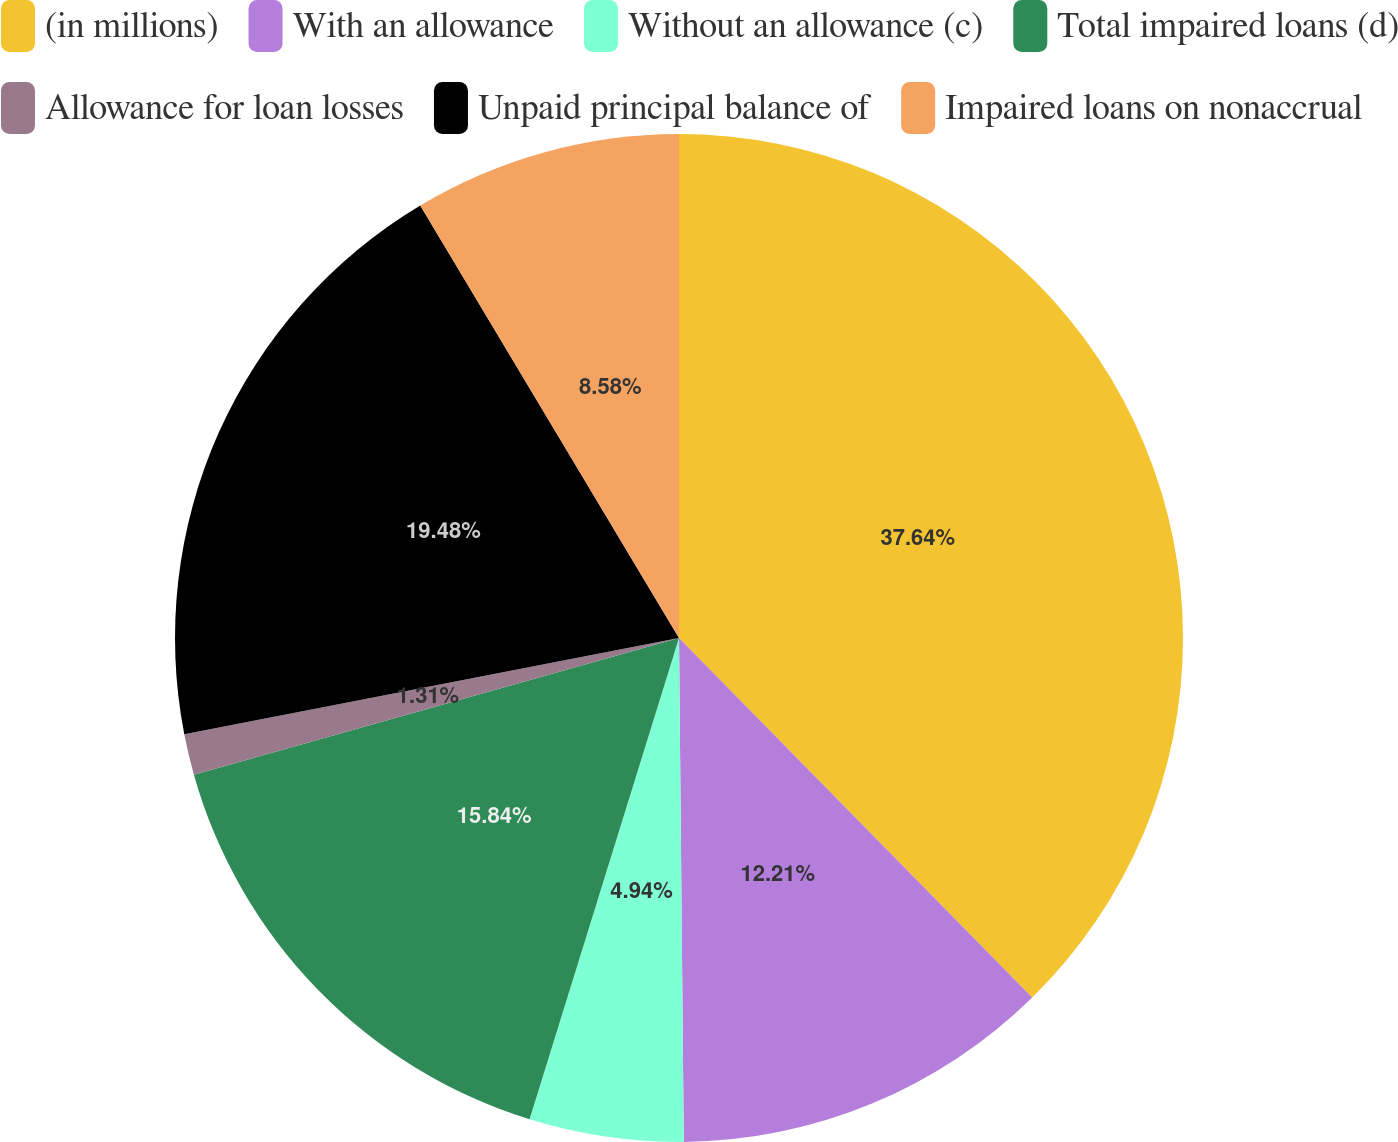<chart> <loc_0><loc_0><loc_500><loc_500><pie_chart><fcel>(in millions)<fcel>With an allowance<fcel>Without an allowance (c)<fcel>Total impaired loans (d)<fcel>Allowance for loan losses<fcel>Unpaid principal balance of<fcel>Impaired loans on nonaccrual<nl><fcel>37.64%<fcel>12.21%<fcel>4.94%<fcel>15.84%<fcel>1.31%<fcel>19.48%<fcel>8.58%<nl></chart> 